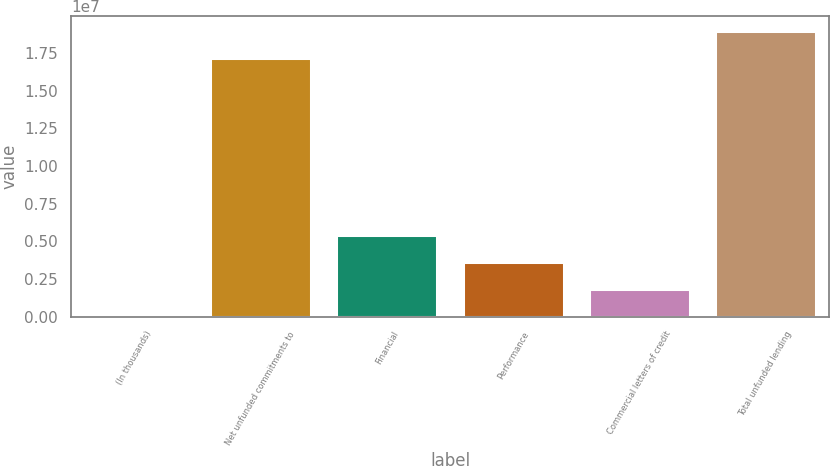Convert chart to OTSL. <chart><loc_0><loc_0><loc_500><loc_500><bar_chart><fcel>(In thousands)<fcel>Net unfunded commitments to<fcel>Financial<fcel>Performance<fcel>Commercial letters of credit<fcel>Total unfunded lending<nl><fcel>2015<fcel>1.71698e+07<fcel>5.4214e+06<fcel>3.61494e+06<fcel>1.80848e+06<fcel>1.89762e+07<nl></chart> 